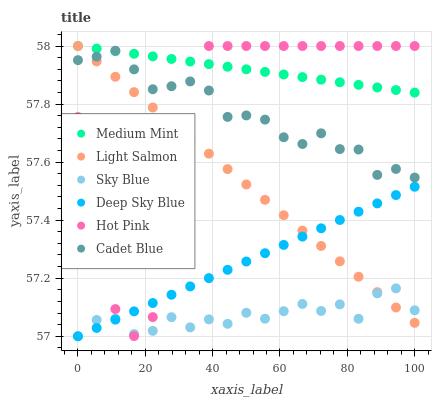Does Sky Blue have the minimum area under the curve?
Answer yes or no. Yes. Does Medium Mint have the maximum area under the curve?
Answer yes or no. Yes. Does Light Salmon have the minimum area under the curve?
Answer yes or no. No. Does Light Salmon have the maximum area under the curve?
Answer yes or no. No. Is Light Salmon the smoothest?
Answer yes or no. Yes. Is Hot Pink the roughest?
Answer yes or no. Yes. Is Cadet Blue the smoothest?
Answer yes or no. No. Is Cadet Blue the roughest?
Answer yes or no. No. Does Deep Sky Blue have the lowest value?
Answer yes or no. Yes. Does Light Salmon have the lowest value?
Answer yes or no. No. Does Hot Pink have the highest value?
Answer yes or no. Yes. Does Cadet Blue have the highest value?
Answer yes or no. No. Is Sky Blue less than Medium Mint?
Answer yes or no. Yes. Is Cadet Blue greater than Deep Sky Blue?
Answer yes or no. Yes. Does Hot Pink intersect Light Salmon?
Answer yes or no. Yes. Is Hot Pink less than Light Salmon?
Answer yes or no. No. Is Hot Pink greater than Light Salmon?
Answer yes or no. No. Does Sky Blue intersect Medium Mint?
Answer yes or no. No. 